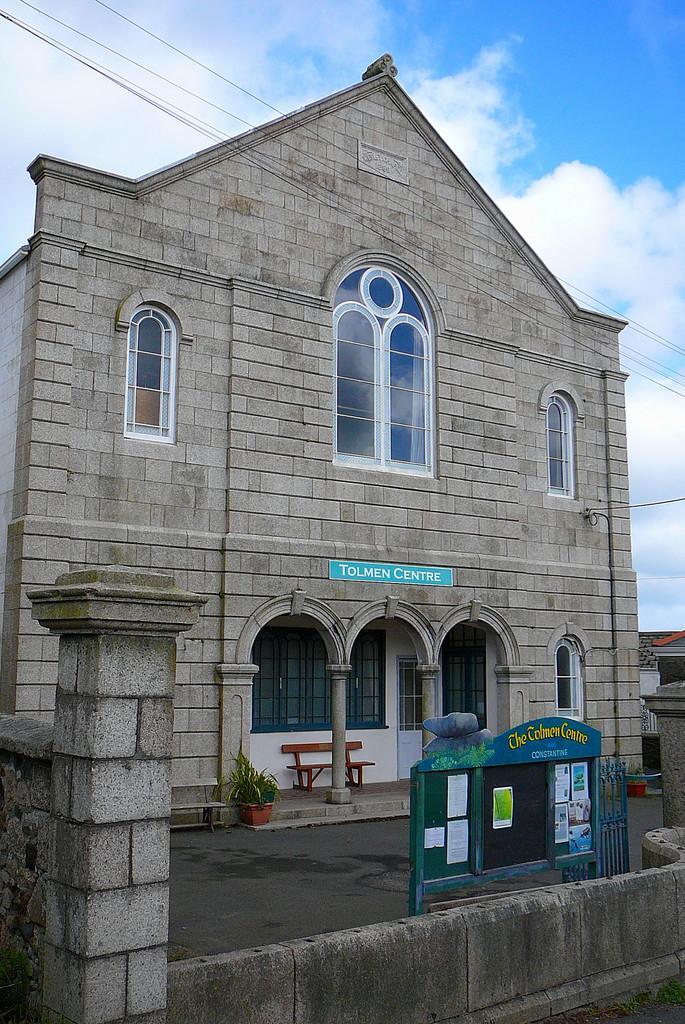Describe this image in one or two sentences. This is the picture of a building. In this image there is a building in the foreground. There is a board behind the wall, on the board there are papers and posters. At the back there are plants and there is a bench and there are windows and there is a door and there is a text on the building. There are buildings on the right side of the image. At the top there is sky and there are clouds and there are wires. 